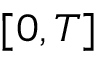<formula> <loc_0><loc_0><loc_500><loc_500>[ 0 , T ]</formula> 